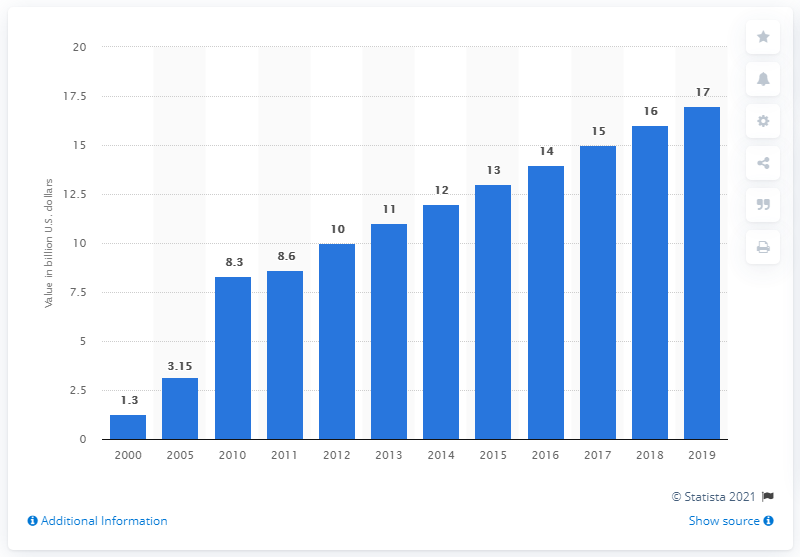Identify some key points in this picture. In 2019, the amount of remittances received in Vietnam was approximately 17... in dollars. 